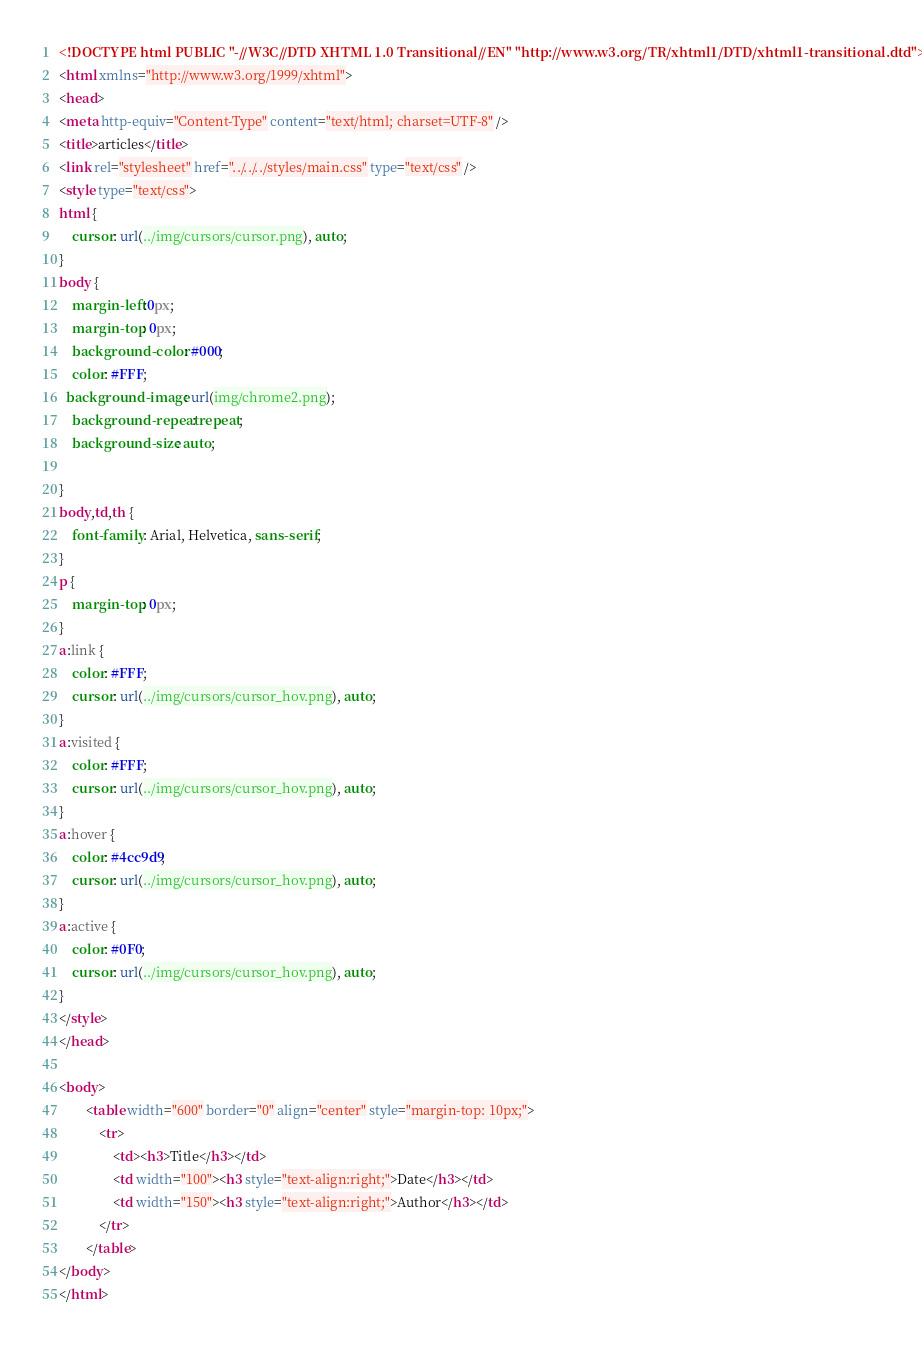Convert code to text. <code><loc_0><loc_0><loc_500><loc_500><_HTML_><!DOCTYPE html PUBLIC "-//W3C//DTD XHTML 1.0 Transitional//EN" "http://www.w3.org/TR/xhtml1/DTD/xhtml1-transitional.dtd">
<html xmlns="http://www.w3.org/1999/xhtml">
<head>
<meta http-equiv="Content-Type" content="text/html; charset=UTF-8" />
<title>articles</title>
<link rel="stylesheet" href="../../../styles/main.css" type="text/css" />
<style type="text/css">
html {
    cursor: url(../img/cursors/cursor.png), auto;
}
body {
	margin-left:0px;
	margin-top: 0px;
	background-color: #000;
	color: #FFF;
  background-image: url(img/chrome2.png);
	background-repeat: repeat;
	background-size: auto;

}
body,td,th {
	font-family: Arial, Helvetica, sans-serif;
}
p {
	margin-top: 0px;
}
a:link {
	color: #FFF;
    cursor: url(../img/cursors/cursor_hov.png), auto;
}
a:visited {
	color: #FFF;
    cursor: url(../img/cursors/cursor_hov.png), auto;
}
a:hover {
	color: #4cc9d9;
    cursor: url(../img/cursors/cursor_hov.png), auto;
}
a:active {
	color: #0F0;
    cursor: url(../img/cursors/cursor_hov.png), auto;
}
</style>
</head>

<body>
		<table width="600" border="0" align="center" style="margin-top: 10px;">
			<tr>
				<td><h3>Title</h3></td>
				<td width="100"><h3 style="text-align:right;">Date</h3></td>
				<td width="150"><h3 style="text-align:right;">Author</h3></td>
			</tr>
		</table>
</body>
</html></code> 